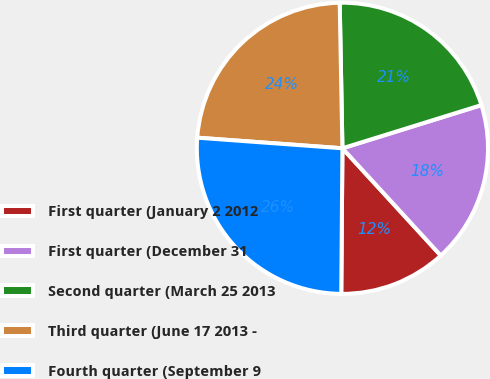Convert chart to OTSL. <chart><loc_0><loc_0><loc_500><loc_500><pie_chart><fcel>First quarter (January 2 2012<fcel>First quarter (December 31<fcel>Second quarter (March 25 2013<fcel>Third quarter (June 17 2013 -<fcel>Fourth quarter (September 9<nl><fcel>11.94%<fcel>17.98%<fcel>20.5%<fcel>23.54%<fcel>26.03%<nl></chart> 